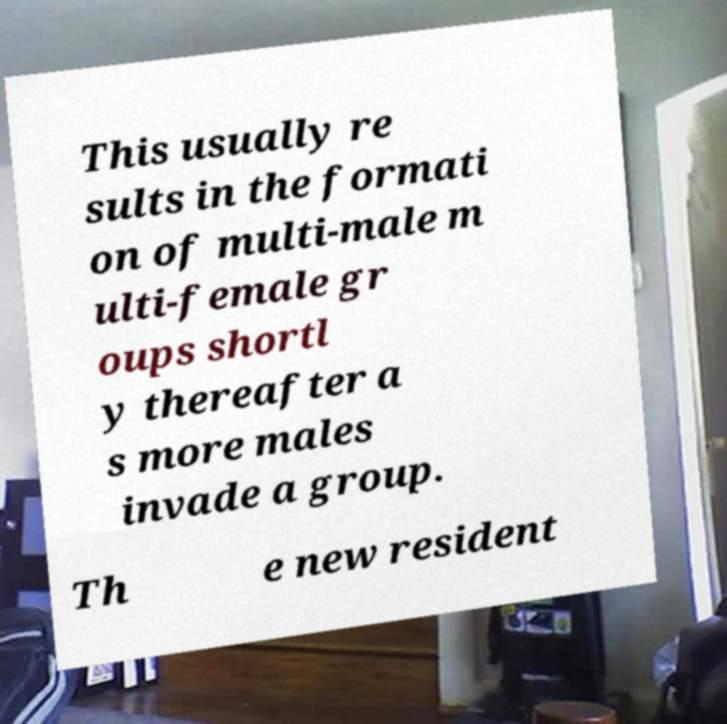For documentation purposes, I need the text within this image transcribed. Could you provide that? This usually re sults in the formati on of multi-male m ulti-female gr oups shortl y thereafter a s more males invade a group. Th e new resident 